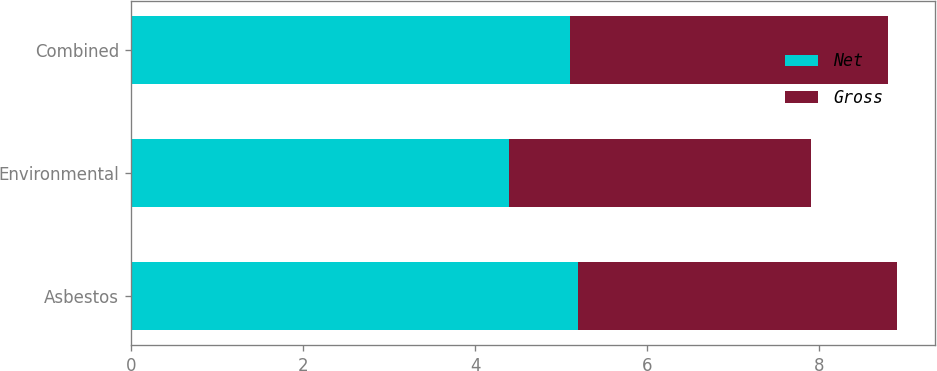Convert chart to OTSL. <chart><loc_0><loc_0><loc_500><loc_500><stacked_bar_chart><ecel><fcel>Asbestos<fcel>Environmental<fcel>Combined<nl><fcel>Net<fcel>5.2<fcel>4.4<fcel>5.1<nl><fcel>Gross<fcel>3.7<fcel>3.5<fcel>3.7<nl></chart> 